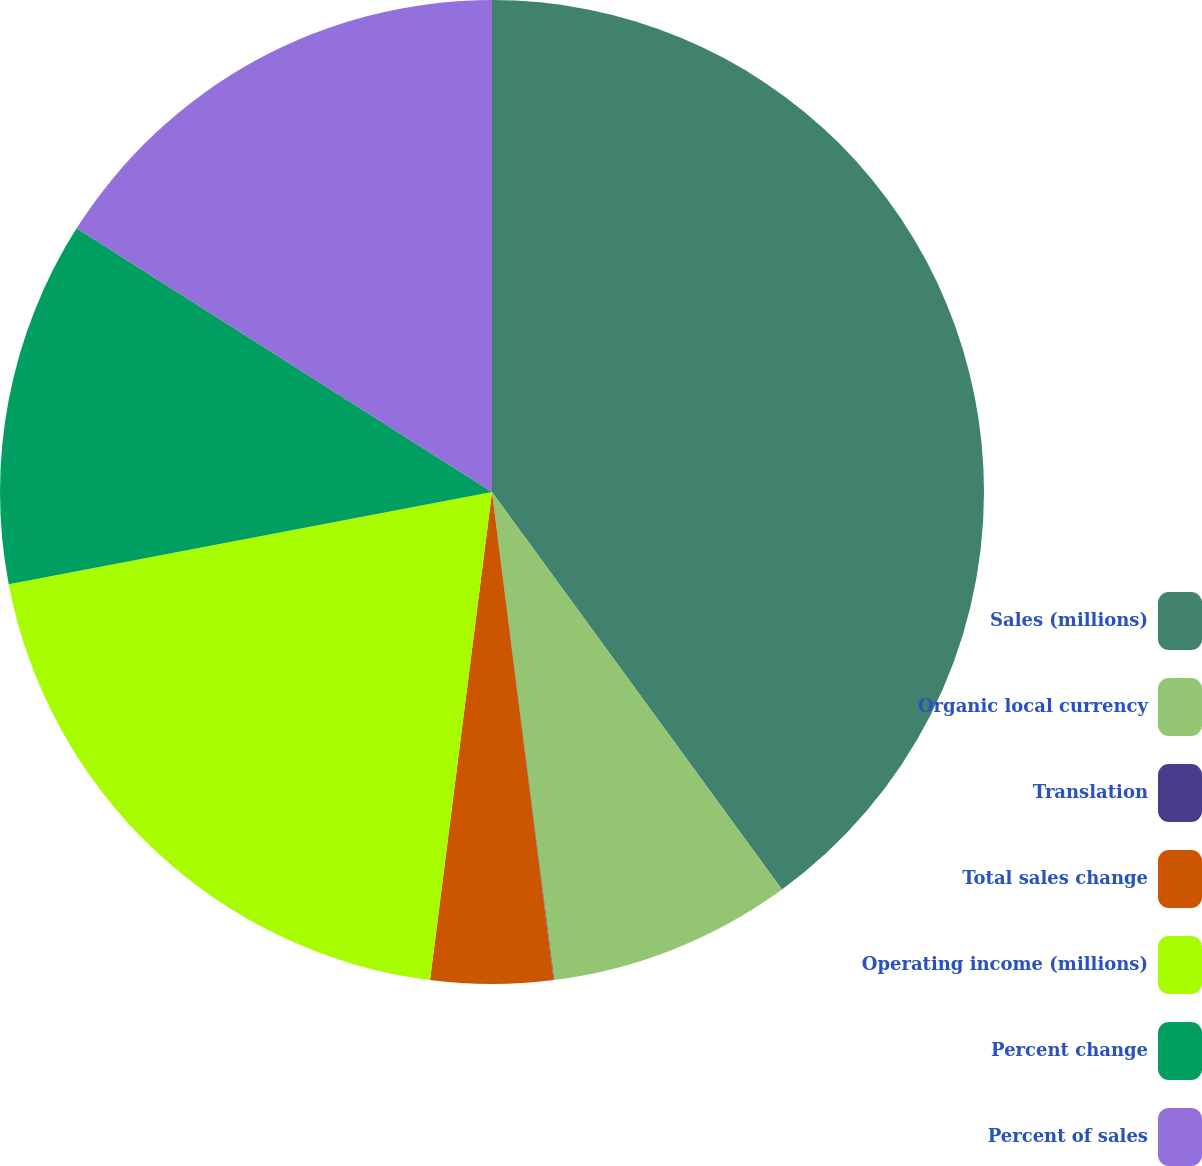Convert chart. <chart><loc_0><loc_0><loc_500><loc_500><pie_chart><fcel>Sales (millions)<fcel>Organic local currency<fcel>Translation<fcel>Total sales change<fcel>Operating income (millions)<fcel>Percent change<fcel>Percent of sales<nl><fcel>39.97%<fcel>8.01%<fcel>0.02%<fcel>4.01%<fcel>19.99%<fcel>12.0%<fcel>16.0%<nl></chart> 